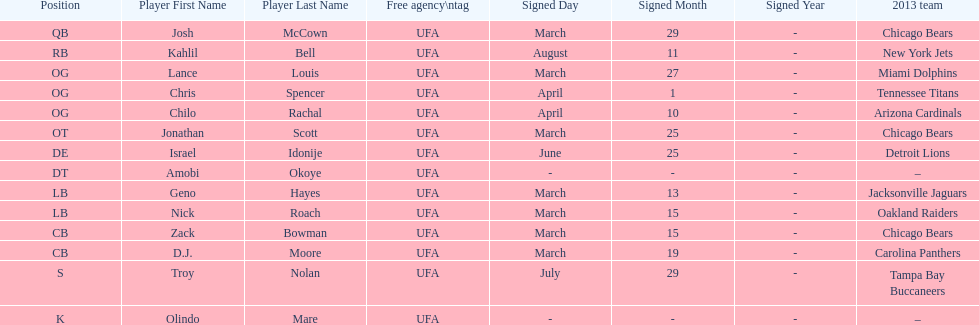Last name is also a first name beginning with "n" Troy Nolan. Would you be able to parse every entry in this table? {'header': ['Position', 'Player First Name', 'Player Last Name', 'Free agency\\ntag', 'Signed Day', 'Signed Month', 'Signed Year', '2013 team'], 'rows': [['QB', 'Josh', 'McCown', 'UFA', 'March', '29', '-', 'Chicago Bears'], ['RB', 'Kahlil', 'Bell', 'UFA', 'August', '11', '-', 'New York Jets'], ['OG', 'Lance', 'Louis', 'UFA', 'March', '27', '-', 'Miami Dolphins'], ['OG', 'Chris', 'Spencer', 'UFA', 'April', '1', '-', 'Tennessee Titans'], ['OG', 'Chilo', 'Rachal', 'UFA', 'April', '10', '-', 'Arizona Cardinals'], ['OT', 'Jonathan', 'Scott', 'UFA', 'March', '25', '-', 'Chicago Bears'], ['DE', 'Israel', 'Idonije', 'UFA', 'June', '25', '-', 'Detroit Lions'], ['DT', 'Amobi', 'Okoye', 'UFA', '-', '-', '-', '–'], ['LB', 'Geno', 'Hayes', 'UFA', 'March', '13', '-', 'Jacksonville Jaguars'], ['LB', 'Nick', 'Roach', 'UFA', 'March', '15', '-', 'Oakland Raiders'], ['CB', 'Zack', 'Bowman', 'UFA', 'March', '15', '-', 'Chicago Bears'], ['CB', 'D.J.', 'Moore', 'UFA', 'March', '19', '-', 'Carolina Panthers'], ['S', 'Troy', 'Nolan', 'UFA', 'July', '29', '-', 'Tampa Bay Buccaneers'], ['K', 'Olindo', 'Mare', 'UFA', '-', '-', '-', '–']]} 